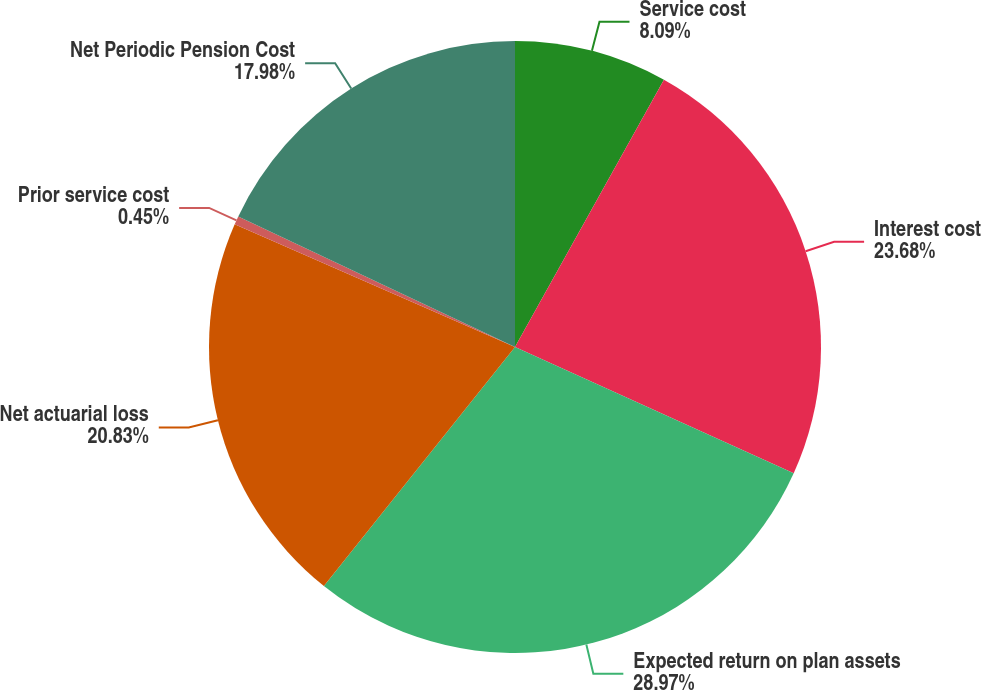<chart> <loc_0><loc_0><loc_500><loc_500><pie_chart><fcel>Service cost<fcel>Interest cost<fcel>Expected return on plan assets<fcel>Net actuarial loss<fcel>Prior service cost<fcel>Net Periodic Pension Cost<nl><fcel>8.09%<fcel>23.68%<fcel>28.96%<fcel>20.83%<fcel>0.45%<fcel>17.98%<nl></chart> 